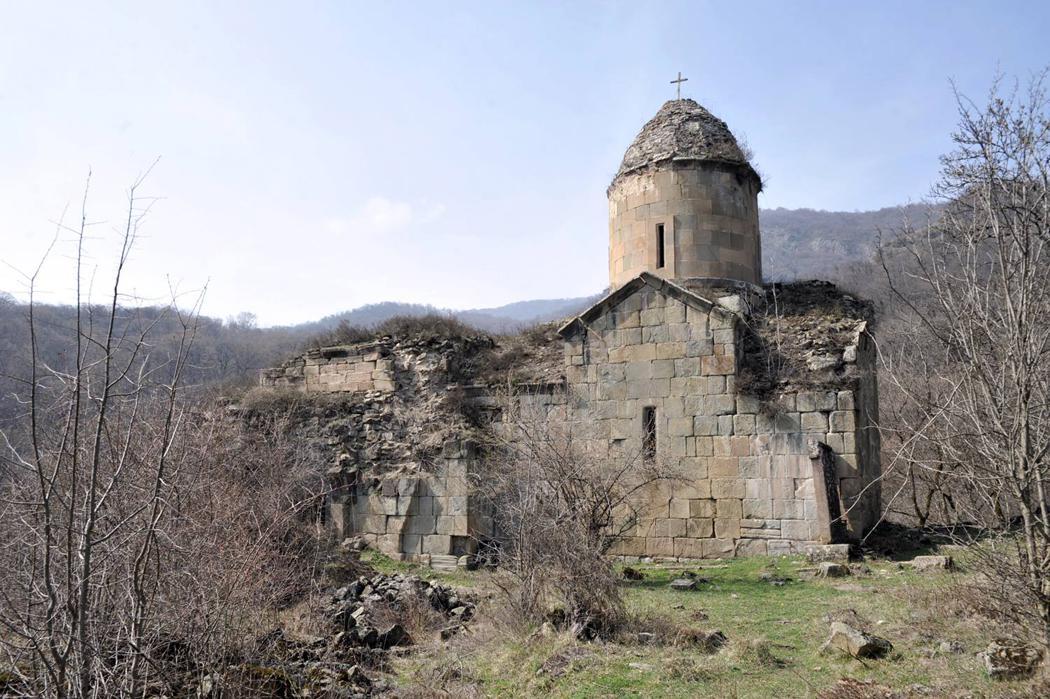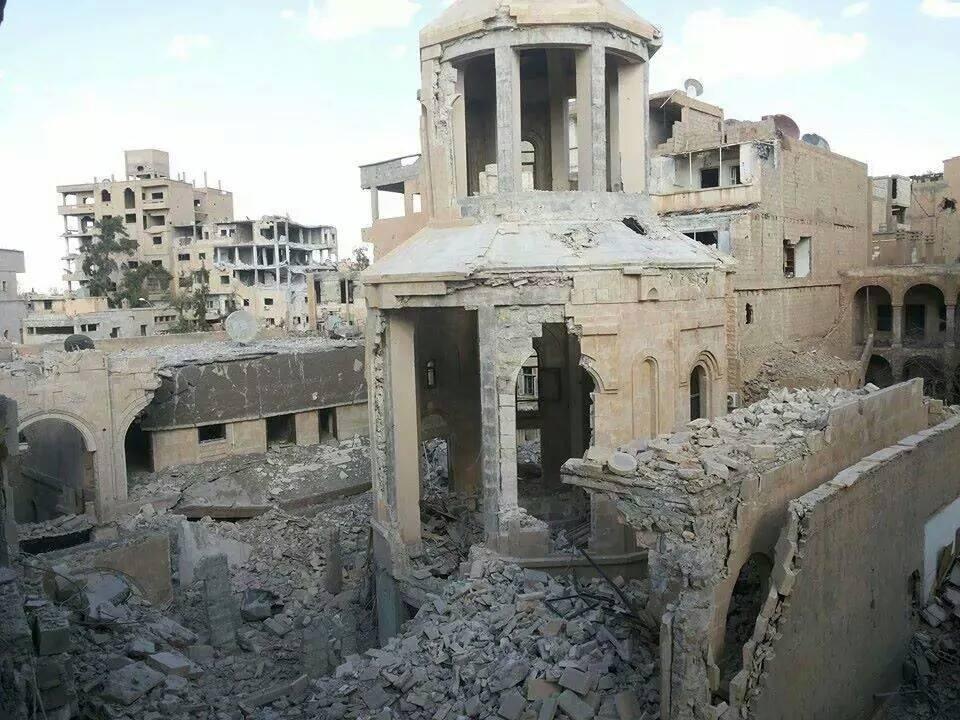The first image is the image on the left, the second image is the image on the right. Analyze the images presented: Is the assertion "There is a cross atop the building in one of the images." valid? Answer yes or no. Yes. 